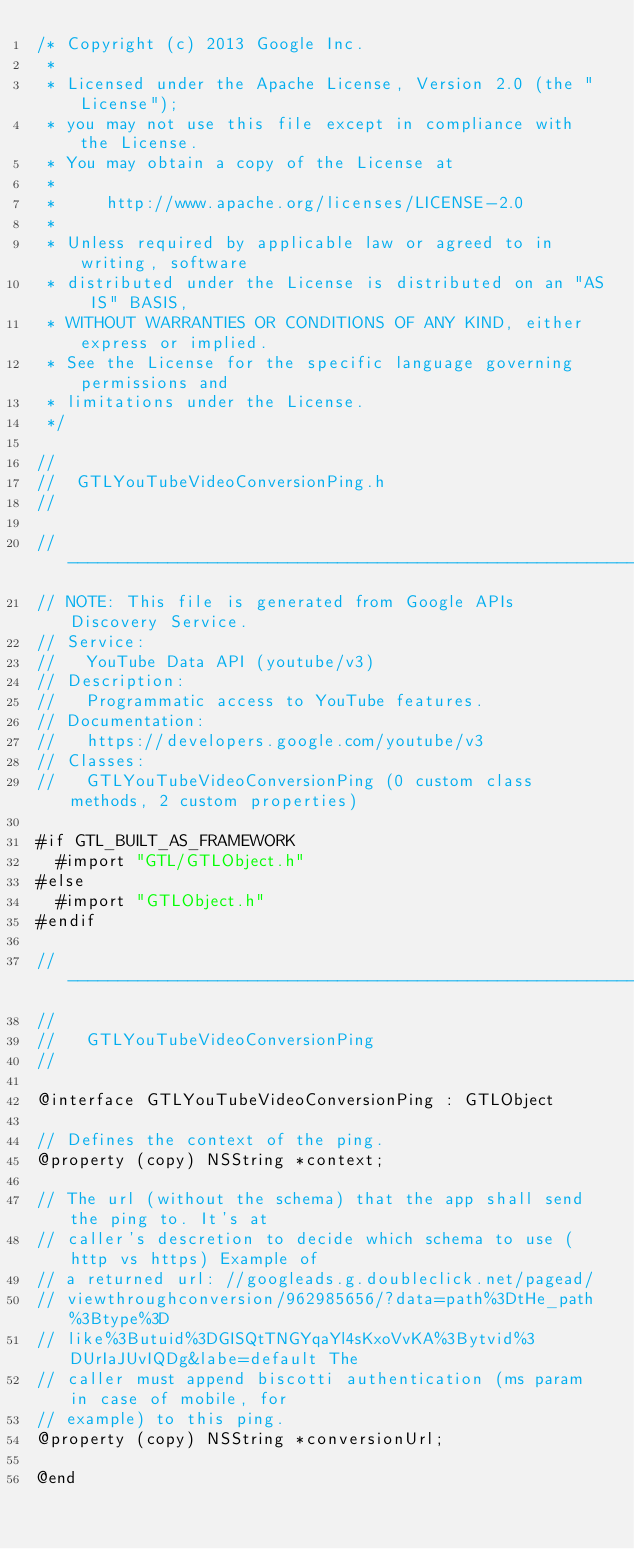<code> <loc_0><loc_0><loc_500><loc_500><_C_>/* Copyright (c) 2013 Google Inc.
 *
 * Licensed under the Apache License, Version 2.0 (the "License");
 * you may not use this file except in compliance with the License.
 * You may obtain a copy of the License at
 *
 *     http://www.apache.org/licenses/LICENSE-2.0
 *
 * Unless required by applicable law or agreed to in writing, software
 * distributed under the License is distributed on an "AS IS" BASIS,
 * WITHOUT WARRANTIES OR CONDITIONS OF ANY KIND, either express or implied.
 * See the License for the specific language governing permissions and
 * limitations under the License.
 */

//
//  GTLYouTubeVideoConversionPing.h
//

// ----------------------------------------------------------------------------
// NOTE: This file is generated from Google APIs Discovery Service.
// Service:
//   YouTube Data API (youtube/v3)
// Description:
//   Programmatic access to YouTube features.
// Documentation:
//   https://developers.google.com/youtube/v3
// Classes:
//   GTLYouTubeVideoConversionPing (0 custom class methods, 2 custom properties)

#if GTL_BUILT_AS_FRAMEWORK
  #import "GTL/GTLObject.h"
#else
  #import "GTLObject.h"
#endif

// ----------------------------------------------------------------------------
//
//   GTLYouTubeVideoConversionPing
//

@interface GTLYouTubeVideoConversionPing : GTLObject

// Defines the context of the ping.
@property (copy) NSString *context;

// The url (without the schema) that the app shall send the ping to. It's at
// caller's descretion to decide which schema to use (http vs https) Example of
// a returned url: //googleads.g.doubleclick.net/pagead/
// viewthroughconversion/962985656/?data=path%3DtHe_path%3Btype%3D
// like%3Butuid%3DGISQtTNGYqaYl4sKxoVvKA%3Bytvid%3DUrIaJUvIQDg&labe=default The
// caller must append biscotti authentication (ms param in case of mobile, for
// example) to this ping.
@property (copy) NSString *conversionUrl;

@end
</code> 